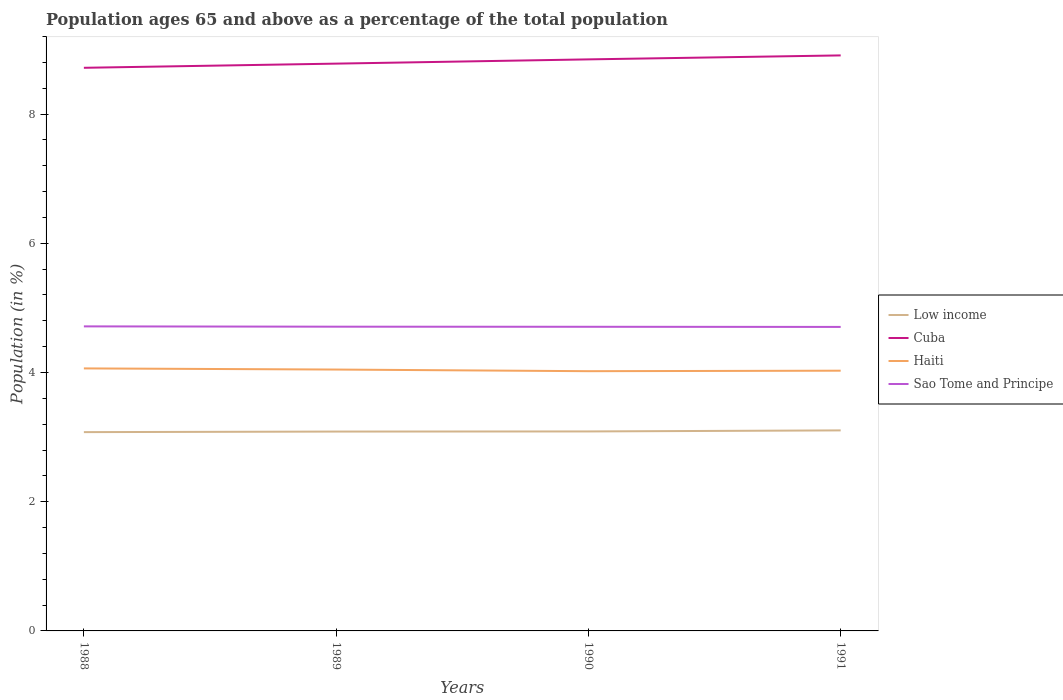How many different coloured lines are there?
Your response must be concise. 4. Across all years, what is the maximum percentage of the population ages 65 and above in Sao Tome and Principe?
Make the answer very short. 4.71. What is the total percentage of the population ages 65 and above in Haiti in the graph?
Provide a succinct answer. 0.03. What is the difference between the highest and the second highest percentage of the population ages 65 and above in Low income?
Provide a succinct answer. 0.03. What is the difference between the highest and the lowest percentage of the population ages 65 and above in Low income?
Your answer should be very brief. 1. Is the percentage of the population ages 65 and above in Haiti strictly greater than the percentage of the population ages 65 and above in Sao Tome and Principe over the years?
Offer a very short reply. Yes. How many lines are there?
Offer a terse response. 4. How many years are there in the graph?
Provide a short and direct response. 4. What is the difference between two consecutive major ticks on the Y-axis?
Provide a short and direct response. 2. Are the values on the major ticks of Y-axis written in scientific E-notation?
Your answer should be compact. No. Does the graph contain grids?
Give a very brief answer. No. How many legend labels are there?
Ensure brevity in your answer.  4. How are the legend labels stacked?
Offer a very short reply. Vertical. What is the title of the graph?
Your answer should be very brief. Population ages 65 and above as a percentage of the total population. What is the Population (in %) of Low income in 1988?
Give a very brief answer. 3.08. What is the Population (in %) of Cuba in 1988?
Your answer should be very brief. 8.72. What is the Population (in %) of Haiti in 1988?
Offer a terse response. 4.06. What is the Population (in %) of Sao Tome and Principe in 1988?
Give a very brief answer. 4.71. What is the Population (in %) in Low income in 1989?
Keep it short and to the point. 3.09. What is the Population (in %) in Cuba in 1989?
Make the answer very short. 8.78. What is the Population (in %) of Haiti in 1989?
Ensure brevity in your answer.  4.05. What is the Population (in %) in Sao Tome and Principe in 1989?
Provide a succinct answer. 4.71. What is the Population (in %) of Low income in 1990?
Your response must be concise. 3.09. What is the Population (in %) in Cuba in 1990?
Your answer should be compact. 8.85. What is the Population (in %) in Haiti in 1990?
Keep it short and to the point. 4.02. What is the Population (in %) in Sao Tome and Principe in 1990?
Provide a succinct answer. 4.71. What is the Population (in %) of Low income in 1991?
Give a very brief answer. 3.1. What is the Population (in %) in Cuba in 1991?
Keep it short and to the point. 8.91. What is the Population (in %) of Haiti in 1991?
Keep it short and to the point. 4.03. What is the Population (in %) in Sao Tome and Principe in 1991?
Your answer should be very brief. 4.71. Across all years, what is the maximum Population (in %) in Low income?
Keep it short and to the point. 3.1. Across all years, what is the maximum Population (in %) in Cuba?
Your response must be concise. 8.91. Across all years, what is the maximum Population (in %) of Haiti?
Ensure brevity in your answer.  4.06. Across all years, what is the maximum Population (in %) in Sao Tome and Principe?
Keep it short and to the point. 4.71. Across all years, what is the minimum Population (in %) in Low income?
Your answer should be compact. 3.08. Across all years, what is the minimum Population (in %) in Cuba?
Give a very brief answer. 8.72. Across all years, what is the minimum Population (in %) in Haiti?
Provide a short and direct response. 4.02. Across all years, what is the minimum Population (in %) of Sao Tome and Principe?
Offer a very short reply. 4.71. What is the total Population (in %) of Low income in the graph?
Give a very brief answer. 12.36. What is the total Population (in %) in Cuba in the graph?
Keep it short and to the point. 35.25. What is the total Population (in %) in Haiti in the graph?
Provide a short and direct response. 16.16. What is the total Population (in %) of Sao Tome and Principe in the graph?
Your answer should be compact. 18.84. What is the difference between the Population (in %) of Low income in 1988 and that in 1989?
Provide a short and direct response. -0.01. What is the difference between the Population (in %) of Cuba in 1988 and that in 1989?
Make the answer very short. -0.06. What is the difference between the Population (in %) in Haiti in 1988 and that in 1989?
Your answer should be very brief. 0.02. What is the difference between the Population (in %) of Sao Tome and Principe in 1988 and that in 1989?
Provide a short and direct response. 0. What is the difference between the Population (in %) of Low income in 1988 and that in 1990?
Provide a succinct answer. -0.01. What is the difference between the Population (in %) of Cuba in 1988 and that in 1990?
Your answer should be very brief. -0.13. What is the difference between the Population (in %) in Haiti in 1988 and that in 1990?
Your response must be concise. 0.04. What is the difference between the Population (in %) in Sao Tome and Principe in 1988 and that in 1990?
Your answer should be very brief. 0.01. What is the difference between the Population (in %) in Low income in 1988 and that in 1991?
Offer a terse response. -0.03. What is the difference between the Population (in %) in Cuba in 1988 and that in 1991?
Make the answer very short. -0.19. What is the difference between the Population (in %) of Haiti in 1988 and that in 1991?
Keep it short and to the point. 0.04. What is the difference between the Population (in %) of Sao Tome and Principe in 1988 and that in 1991?
Ensure brevity in your answer.  0.01. What is the difference between the Population (in %) in Low income in 1989 and that in 1990?
Your answer should be very brief. -0. What is the difference between the Population (in %) of Cuba in 1989 and that in 1990?
Give a very brief answer. -0.07. What is the difference between the Population (in %) in Haiti in 1989 and that in 1990?
Offer a terse response. 0.03. What is the difference between the Population (in %) in Sao Tome and Principe in 1989 and that in 1990?
Keep it short and to the point. 0. What is the difference between the Population (in %) of Low income in 1989 and that in 1991?
Make the answer very short. -0.02. What is the difference between the Population (in %) in Cuba in 1989 and that in 1991?
Offer a very short reply. -0.13. What is the difference between the Population (in %) in Haiti in 1989 and that in 1991?
Your answer should be compact. 0.02. What is the difference between the Population (in %) in Sao Tome and Principe in 1989 and that in 1991?
Offer a very short reply. 0. What is the difference between the Population (in %) in Low income in 1990 and that in 1991?
Offer a very short reply. -0.02. What is the difference between the Population (in %) in Cuba in 1990 and that in 1991?
Give a very brief answer. -0.06. What is the difference between the Population (in %) in Haiti in 1990 and that in 1991?
Your answer should be very brief. -0.01. What is the difference between the Population (in %) of Sao Tome and Principe in 1990 and that in 1991?
Keep it short and to the point. 0. What is the difference between the Population (in %) in Low income in 1988 and the Population (in %) in Cuba in 1989?
Your answer should be very brief. -5.7. What is the difference between the Population (in %) in Low income in 1988 and the Population (in %) in Haiti in 1989?
Make the answer very short. -0.97. What is the difference between the Population (in %) in Low income in 1988 and the Population (in %) in Sao Tome and Principe in 1989?
Your answer should be very brief. -1.63. What is the difference between the Population (in %) in Cuba in 1988 and the Population (in %) in Haiti in 1989?
Ensure brevity in your answer.  4.67. What is the difference between the Population (in %) in Cuba in 1988 and the Population (in %) in Sao Tome and Principe in 1989?
Provide a succinct answer. 4.01. What is the difference between the Population (in %) of Haiti in 1988 and the Population (in %) of Sao Tome and Principe in 1989?
Your response must be concise. -0.65. What is the difference between the Population (in %) in Low income in 1988 and the Population (in %) in Cuba in 1990?
Provide a succinct answer. -5.77. What is the difference between the Population (in %) in Low income in 1988 and the Population (in %) in Haiti in 1990?
Your response must be concise. -0.94. What is the difference between the Population (in %) of Low income in 1988 and the Population (in %) of Sao Tome and Principe in 1990?
Offer a terse response. -1.63. What is the difference between the Population (in %) in Cuba in 1988 and the Population (in %) in Haiti in 1990?
Make the answer very short. 4.7. What is the difference between the Population (in %) of Cuba in 1988 and the Population (in %) of Sao Tome and Principe in 1990?
Keep it short and to the point. 4.01. What is the difference between the Population (in %) in Haiti in 1988 and the Population (in %) in Sao Tome and Principe in 1990?
Your answer should be very brief. -0.64. What is the difference between the Population (in %) of Low income in 1988 and the Population (in %) of Cuba in 1991?
Give a very brief answer. -5.83. What is the difference between the Population (in %) of Low income in 1988 and the Population (in %) of Haiti in 1991?
Offer a very short reply. -0.95. What is the difference between the Population (in %) in Low income in 1988 and the Population (in %) in Sao Tome and Principe in 1991?
Your response must be concise. -1.63. What is the difference between the Population (in %) of Cuba in 1988 and the Population (in %) of Haiti in 1991?
Offer a terse response. 4.69. What is the difference between the Population (in %) in Cuba in 1988 and the Population (in %) in Sao Tome and Principe in 1991?
Keep it short and to the point. 4.01. What is the difference between the Population (in %) of Haiti in 1988 and the Population (in %) of Sao Tome and Principe in 1991?
Provide a succinct answer. -0.64. What is the difference between the Population (in %) in Low income in 1989 and the Population (in %) in Cuba in 1990?
Your response must be concise. -5.76. What is the difference between the Population (in %) of Low income in 1989 and the Population (in %) of Haiti in 1990?
Your response must be concise. -0.93. What is the difference between the Population (in %) in Low income in 1989 and the Population (in %) in Sao Tome and Principe in 1990?
Your answer should be very brief. -1.62. What is the difference between the Population (in %) of Cuba in 1989 and the Population (in %) of Haiti in 1990?
Offer a very short reply. 4.76. What is the difference between the Population (in %) in Cuba in 1989 and the Population (in %) in Sao Tome and Principe in 1990?
Give a very brief answer. 4.07. What is the difference between the Population (in %) of Haiti in 1989 and the Population (in %) of Sao Tome and Principe in 1990?
Ensure brevity in your answer.  -0.66. What is the difference between the Population (in %) of Low income in 1989 and the Population (in %) of Cuba in 1991?
Give a very brief answer. -5.82. What is the difference between the Population (in %) of Low income in 1989 and the Population (in %) of Haiti in 1991?
Provide a succinct answer. -0.94. What is the difference between the Population (in %) in Low income in 1989 and the Population (in %) in Sao Tome and Principe in 1991?
Your answer should be very brief. -1.62. What is the difference between the Population (in %) in Cuba in 1989 and the Population (in %) in Haiti in 1991?
Your answer should be compact. 4.75. What is the difference between the Population (in %) in Cuba in 1989 and the Population (in %) in Sao Tome and Principe in 1991?
Provide a succinct answer. 4.08. What is the difference between the Population (in %) in Haiti in 1989 and the Population (in %) in Sao Tome and Principe in 1991?
Provide a short and direct response. -0.66. What is the difference between the Population (in %) in Low income in 1990 and the Population (in %) in Cuba in 1991?
Make the answer very short. -5.82. What is the difference between the Population (in %) of Low income in 1990 and the Population (in %) of Haiti in 1991?
Your response must be concise. -0.94. What is the difference between the Population (in %) of Low income in 1990 and the Population (in %) of Sao Tome and Principe in 1991?
Your answer should be compact. -1.62. What is the difference between the Population (in %) of Cuba in 1990 and the Population (in %) of Haiti in 1991?
Provide a short and direct response. 4.82. What is the difference between the Population (in %) of Cuba in 1990 and the Population (in %) of Sao Tome and Principe in 1991?
Ensure brevity in your answer.  4.14. What is the difference between the Population (in %) of Haiti in 1990 and the Population (in %) of Sao Tome and Principe in 1991?
Ensure brevity in your answer.  -0.69. What is the average Population (in %) in Low income per year?
Make the answer very short. 3.09. What is the average Population (in %) of Cuba per year?
Keep it short and to the point. 8.81. What is the average Population (in %) in Haiti per year?
Your answer should be very brief. 4.04. What is the average Population (in %) of Sao Tome and Principe per year?
Your answer should be compact. 4.71. In the year 1988, what is the difference between the Population (in %) of Low income and Population (in %) of Cuba?
Offer a very short reply. -5.64. In the year 1988, what is the difference between the Population (in %) in Low income and Population (in %) in Haiti?
Provide a succinct answer. -0.99. In the year 1988, what is the difference between the Population (in %) of Low income and Population (in %) of Sao Tome and Principe?
Keep it short and to the point. -1.64. In the year 1988, what is the difference between the Population (in %) in Cuba and Population (in %) in Haiti?
Give a very brief answer. 4.65. In the year 1988, what is the difference between the Population (in %) of Cuba and Population (in %) of Sao Tome and Principe?
Offer a very short reply. 4. In the year 1988, what is the difference between the Population (in %) in Haiti and Population (in %) in Sao Tome and Principe?
Your response must be concise. -0.65. In the year 1989, what is the difference between the Population (in %) of Low income and Population (in %) of Cuba?
Your response must be concise. -5.7. In the year 1989, what is the difference between the Population (in %) in Low income and Population (in %) in Haiti?
Your response must be concise. -0.96. In the year 1989, what is the difference between the Population (in %) in Low income and Population (in %) in Sao Tome and Principe?
Offer a terse response. -1.62. In the year 1989, what is the difference between the Population (in %) of Cuba and Population (in %) of Haiti?
Your answer should be compact. 4.74. In the year 1989, what is the difference between the Population (in %) of Cuba and Population (in %) of Sao Tome and Principe?
Ensure brevity in your answer.  4.07. In the year 1989, what is the difference between the Population (in %) of Haiti and Population (in %) of Sao Tome and Principe?
Your response must be concise. -0.66. In the year 1990, what is the difference between the Population (in %) in Low income and Population (in %) in Cuba?
Make the answer very short. -5.76. In the year 1990, what is the difference between the Population (in %) of Low income and Population (in %) of Haiti?
Provide a short and direct response. -0.93. In the year 1990, what is the difference between the Population (in %) of Low income and Population (in %) of Sao Tome and Principe?
Give a very brief answer. -1.62. In the year 1990, what is the difference between the Population (in %) in Cuba and Population (in %) in Haiti?
Keep it short and to the point. 4.83. In the year 1990, what is the difference between the Population (in %) of Cuba and Population (in %) of Sao Tome and Principe?
Your answer should be compact. 4.14. In the year 1990, what is the difference between the Population (in %) in Haiti and Population (in %) in Sao Tome and Principe?
Offer a terse response. -0.69. In the year 1991, what is the difference between the Population (in %) of Low income and Population (in %) of Cuba?
Provide a short and direct response. -5.8. In the year 1991, what is the difference between the Population (in %) in Low income and Population (in %) in Haiti?
Provide a succinct answer. -0.92. In the year 1991, what is the difference between the Population (in %) in Low income and Population (in %) in Sao Tome and Principe?
Your answer should be very brief. -1.6. In the year 1991, what is the difference between the Population (in %) of Cuba and Population (in %) of Haiti?
Give a very brief answer. 4.88. In the year 1991, what is the difference between the Population (in %) of Cuba and Population (in %) of Sao Tome and Principe?
Provide a succinct answer. 4.2. In the year 1991, what is the difference between the Population (in %) of Haiti and Population (in %) of Sao Tome and Principe?
Your response must be concise. -0.68. What is the ratio of the Population (in %) in Low income in 1988 to that in 1989?
Your response must be concise. 1. What is the ratio of the Population (in %) of Cuba in 1988 to that in 1989?
Your answer should be very brief. 0.99. What is the ratio of the Population (in %) of Sao Tome and Principe in 1988 to that in 1989?
Keep it short and to the point. 1. What is the ratio of the Population (in %) in Cuba in 1988 to that in 1990?
Your answer should be compact. 0.99. What is the ratio of the Population (in %) of Haiti in 1988 to that in 1990?
Offer a very short reply. 1.01. What is the ratio of the Population (in %) in Sao Tome and Principe in 1988 to that in 1990?
Give a very brief answer. 1. What is the ratio of the Population (in %) of Cuba in 1988 to that in 1991?
Ensure brevity in your answer.  0.98. What is the ratio of the Population (in %) of Haiti in 1988 to that in 1991?
Make the answer very short. 1.01. What is the ratio of the Population (in %) of Sao Tome and Principe in 1988 to that in 1991?
Your response must be concise. 1. What is the ratio of the Population (in %) of Cuba in 1989 to that in 1990?
Provide a short and direct response. 0.99. What is the ratio of the Population (in %) of Haiti in 1989 to that in 1990?
Provide a succinct answer. 1.01. What is the ratio of the Population (in %) of Low income in 1989 to that in 1991?
Make the answer very short. 0.99. What is the ratio of the Population (in %) of Cuba in 1989 to that in 1991?
Offer a terse response. 0.99. What is the ratio of the Population (in %) in Haiti in 1989 to that in 1991?
Your answer should be very brief. 1. What is the ratio of the Population (in %) of Sao Tome and Principe in 1989 to that in 1991?
Your response must be concise. 1. What is the ratio of the Population (in %) in Low income in 1990 to that in 1991?
Offer a very short reply. 0.99. What is the ratio of the Population (in %) in Cuba in 1990 to that in 1991?
Make the answer very short. 0.99. What is the difference between the highest and the second highest Population (in %) of Low income?
Keep it short and to the point. 0.02. What is the difference between the highest and the second highest Population (in %) in Cuba?
Give a very brief answer. 0.06. What is the difference between the highest and the second highest Population (in %) in Haiti?
Offer a terse response. 0.02. What is the difference between the highest and the second highest Population (in %) of Sao Tome and Principe?
Provide a short and direct response. 0. What is the difference between the highest and the lowest Population (in %) in Low income?
Ensure brevity in your answer.  0.03. What is the difference between the highest and the lowest Population (in %) in Cuba?
Make the answer very short. 0.19. What is the difference between the highest and the lowest Population (in %) in Haiti?
Ensure brevity in your answer.  0.04. What is the difference between the highest and the lowest Population (in %) of Sao Tome and Principe?
Make the answer very short. 0.01. 